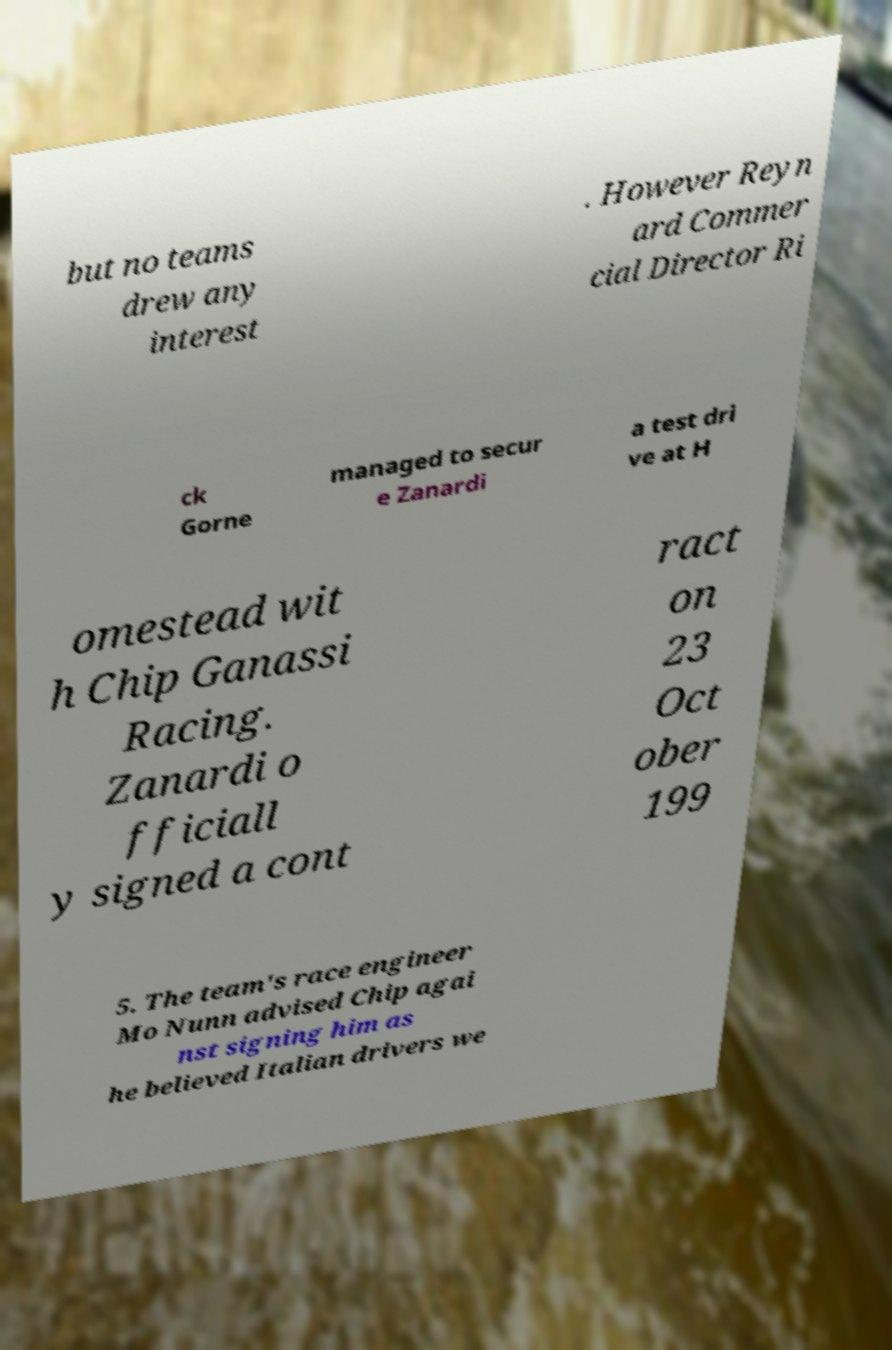I need the written content from this picture converted into text. Can you do that? but no teams drew any interest . However Reyn ard Commer cial Director Ri ck Gorne managed to secur e Zanardi a test dri ve at H omestead wit h Chip Ganassi Racing. Zanardi o fficiall y signed a cont ract on 23 Oct ober 199 5. The team's race engineer Mo Nunn advised Chip agai nst signing him as he believed Italian drivers we 